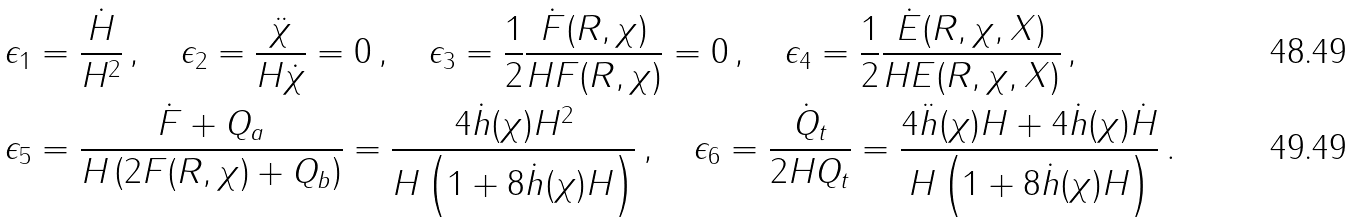<formula> <loc_0><loc_0><loc_500><loc_500>& \epsilon _ { 1 } = \frac { \dot { H } } { H ^ { 2 } } \, , \quad \epsilon _ { 2 } = \frac { \ddot { \chi } } { H \dot { \chi } } = 0 \, , \quad \epsilon _ { 3 } = \frac { 1 } { 2 } \frac { \dot { F } ( R , \chi ) } { H F ( R , \chi ) } = 0 \, , \quad \epsilon _ { 4 } = \frac { 1 } { 2 } \frac { \dot { E } ( R , \chi , X ) } { H E ( R , \chi , X ) } \, , \\ & \epsilon _ { 5 } = \frac { \dot { F } + Q _ { a } } { H \left ( 2 F ( R , \chi ) + Q _ { b } \right ) } = \frac { 4 \dot { h } ( \chi ) H ^ { 2 } } { H \left ( 1 + 8 \dot { h } ( \chi ) H \right ) } \, , \quad \epsilon _ { 6 } = \frac { \dot { Q } _ { t } } { 2 H Q _ { t } } = \frac { 4 \ddot { h } ( \chi ) H + 4 \dot { h } ( \chi ) \dot { H } } { H \left ( 1 + 8 \dot { h } ( \chi ) H \right ) } \, .</formula> 